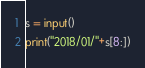<code> <loc_0><loc_0><loc_500><loc_500><_Python_>s = input()
print("2018/01/"+s[8:])
</code> 